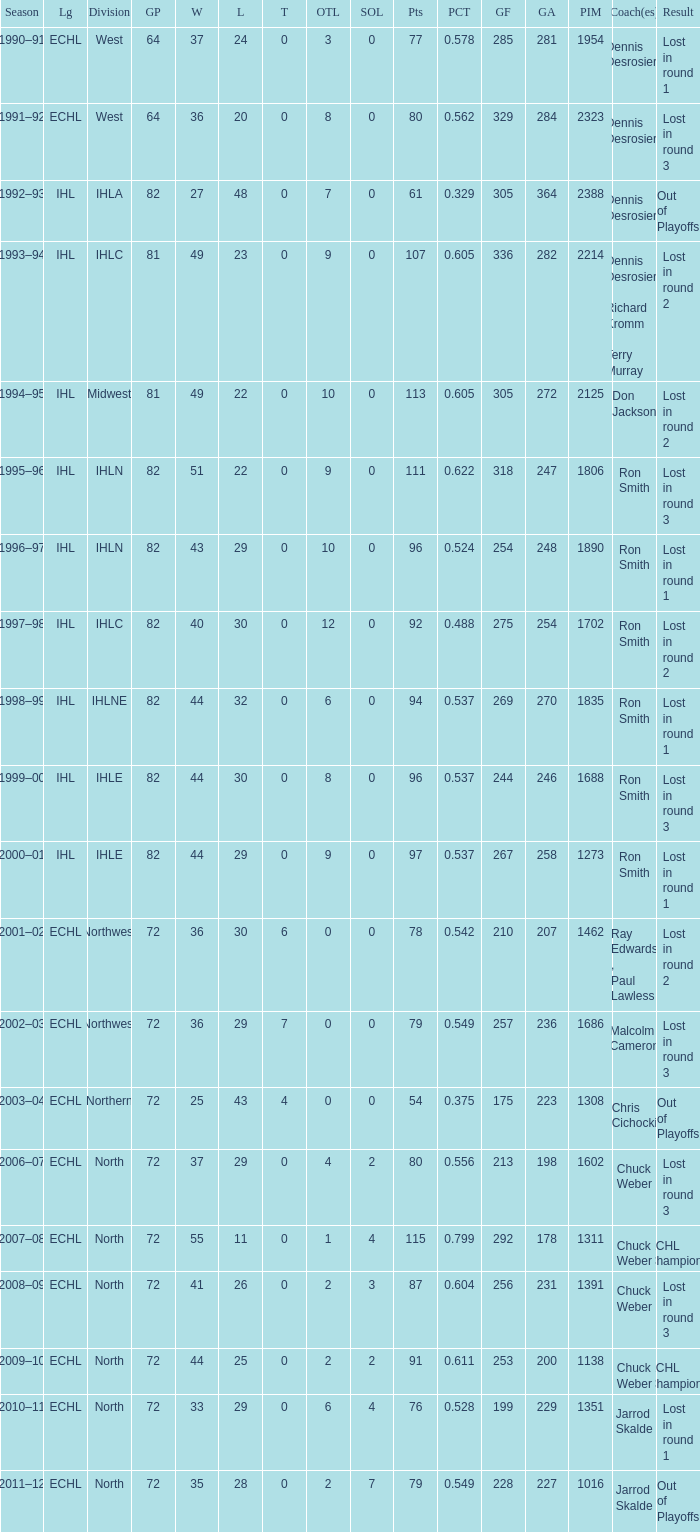Could you parse the entire table? {'header': ['Season', 'Lg', 'Division', 'GP', 'W', 'L', 'T', 'OTL', 'SOL', 'Pts', 'PCT', 'GF', 'GA', 'PIM', 'Coach(es)', 'Result'], 'rows': [['1990–91', 'ECHL', 'West', '64', '37', '24', '0', '3', '0', '77', '0.578', '285', '281', '1954', 'Dennis Desrosiers', 'Lost in round 1'], ['1991–92', 'ECHL', 'West', '64', '36', '20', '0', '8', '0', '80', '0.562', '329', '284', '2323', 'Dennis Desrosiers', 'Lost in round 3'], ['1992–93', 'IHL', 'IHLA', '82', '27', '48', '0', '7', '0', '61', '0.329', '305', '364', '2388', 'Dennis Desrosiers', 'Out of Playoffs'], ['1993–94', 'IHL', 'IHLC', '81', '49', '23', '0', '9', '0', '107', '0.605', '336', '282', '2214', 'Dennis Desrosiers , Richard Kromm , Terry Murray', 'Lost in round 2'], ['1994–95', 'IHL', 'Midwest', '81', '49', '22', '0', '10', '0', '113', '0.605', '305', '272', '2125', 'Don Jackson', 'Lost in round 2'], ['1995–96', 'IHL', 'IHLN', '82', '51', '22', '0', '9', '0', '111', '0.622', '318', '247', '1806', 'Ron Smith', 'Lost in round 3'], ['1996–97', 'IHL', 'IHLN', '82', '43', '29', '0', '10', '0', '96', '0.524', '254', '248', '1890', 'Ron Smith', 'Lost in round 1'], ['1997–98', 'IHL', 'IHLC', '82', '40', '30', '0', '12', '0', '92', '0.488', '275', '254', '1702', 'Ron Smith', 'Lost in round 2'], ['1998–99', 'IHL', 'IHLNE', '82', '44', '32', '0', '6', '0', '94', '0.537', '269', '270', '1835', 'Ron Smith', 'Lost in round 1'], ['1999–00', 'IHL', 'IHLE', '82', '44', '30', '0', '8', '0', '96', '0.537', '244', '246', '1688', 'Ron Smith', 'Lost in round 3'], ['2000–01', 'IHL', 'IHLE', '82', '44', '29', '0', '9', '0', '97', '0.537', '267', '258', '1273', 'Ron Smith', 'Lost in round 1'], ['2001–02', 'ECHL', 'Northwest', '72', '36', '30', '6', '0', '0', '78', '0.542', '210', '207', '1462', 'Ray Edwards , Paul Lawless', 'Lost in round 2'], ['2002–03', 'ECHL', 'Northwest', '72', '36', '29', '7', '0', '0', '79', '0.549', '257', '236', '1686', 'Malcolm Cameron', 'Lost in round 3'], ['2003–04', 'ECHL', 'Northern', '72', '25', '43', '4', '0', '0', '54', '0.375', '175', '223', '1308', 'Chris Cichocki', 'Out of Playoffs'], ['2006–07', 'ECHL', 'North', '72', '37', '29', '0', '4', '2', '80', '0.556', '213', '198', '1602', 'Chuck Weber', 'Lost in round 3'], ['2007–08', 'ECHL', 'North', '72', '55', '11', '0', '1', '4', '115', '0.799', '292', '178', '1311', 'Chuck Weber', 'ECHL Champions'], ['2008–09', 'ECHL', 'North', '72', '41', '26', '0', '2', '3', '87', '0.604', '256', '231', '1391', 'Chuck Weber', 'Lost in round 3'], ['2009–10', 'ECHL', 'North', '72', '44', '25', '0', '2', '2', '91', '0.611', '253', '200', '1138', 'Chuck Weber', 'ECHL Champions'], ['2010–11', 'ECHL', 'North', '72', '33', '29', '0', '6', '4', '76', '0.528', '199', '229', '1351', 'Jarrod Skalde', 'Lost in round 1'], ['2011–12', 'ECHL', 'North', '72', '35', '28', '0', '2', '7', '79', '0.549', '228', '227', '1016', 'Jarrod Skalde', 'Out of Playoffs']]} What was the minimum L if the GA is 272? 22.0. 